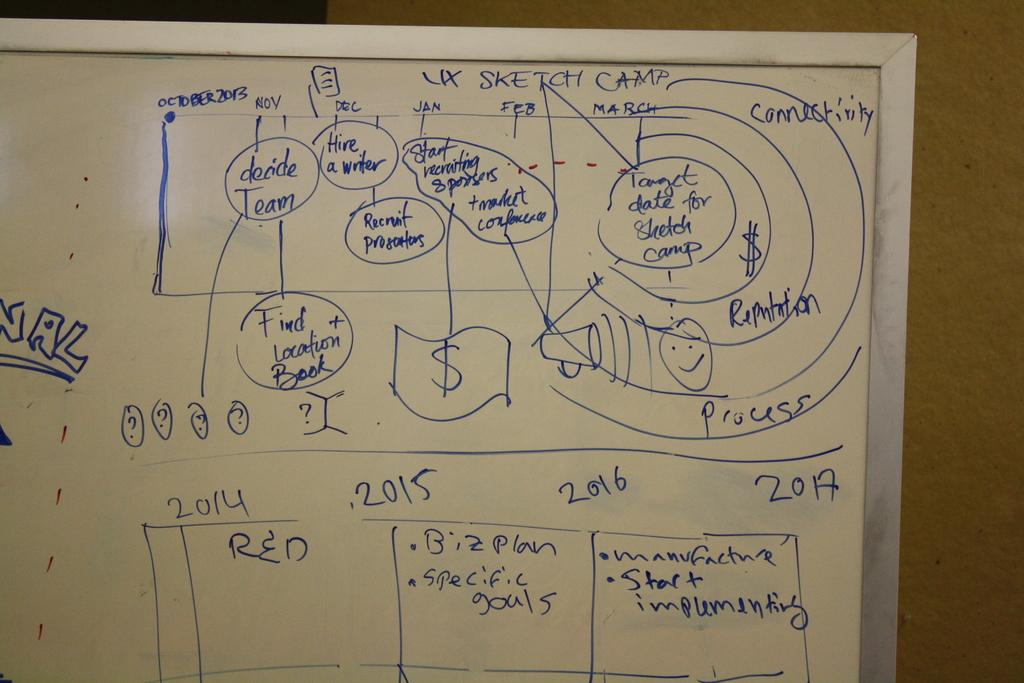What is the main object in the image? There is a whiteboard in the image. What is written or drawn on the whiteboard? The whiteboard has text on it. What can be seen in the background of the image? There is a wall in the background of the image. Can you see any icicles hanging from the wall in the image? There are no icicles visible in the image; only the whiteboard and text are present. 